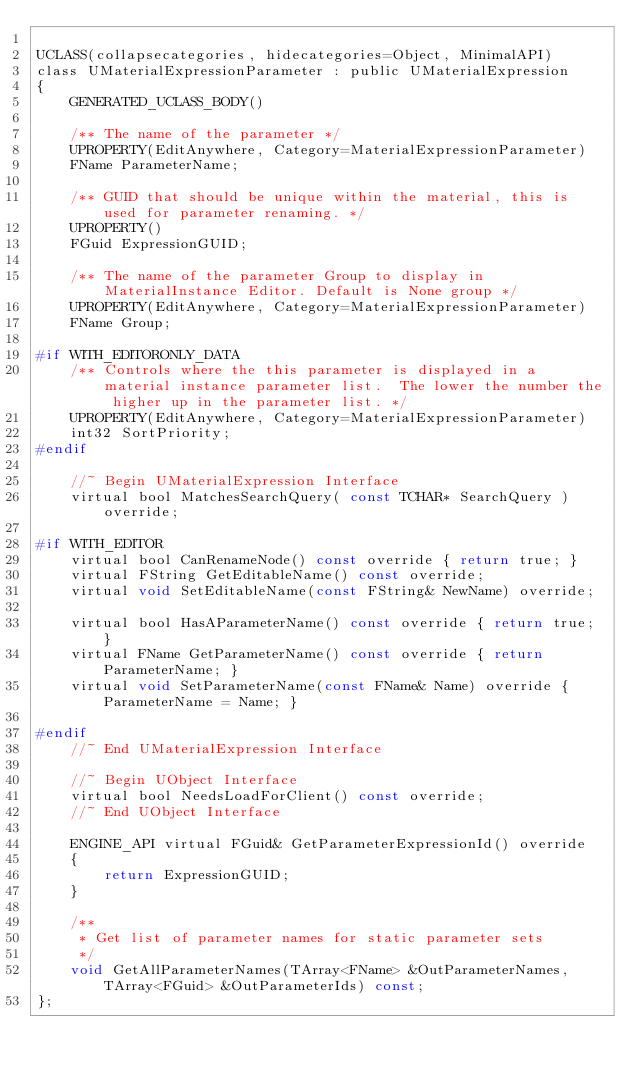<code> <loc_0><loc_0><loc_500><loc_500><_C_>
UCLASS(collapsecategories, hidecategories=Object, MinimalAPI)
class UMaterialExpressionParameter : public UMaterialExpression
{
	GENERATED_UCLASS_BODY()

	/** The name of the parameter */
	UPROPERTY(EditAnywhere, Category=MaterialExpressionParameter)
	FName ParameterName;

	/** GUID that should be unique within the material, this is used for parameter renaming. */
	UPROPERTY()
	FGuid ExpressionGUID;

	/** The name of the parameter Group to display in MaterialInstance Editor. Default is None group */
	UPROPERTY(EditAnywhere, Category=MaterialExpressionParameter)
	FName Group;

#if WITH_EDITORONLY_DATA
	/** Controls where the this parameter is displayed in a material instance parameter list.  The lower the number the higher up in the parameter list. */
	UPROPERTY(EditAnywhere, Category=MaterialExpressionParameter)
	int32 SortPriority;
#endif

	//~ Begin UMaterialExpression Interface
	virtual bool MatchesSearchQuery( const TCHAR* SearchQuery ) override;

#if WITH_EDITOR
	virtual bool CanRenameNode() const override { return true; }
	virtual FString GetEditableName() const override;
	virtual void SetEditableName(const FString& NewName) override;

	virtual bool HasAParameterName() const override { return true; }
	virtual FName GetParameterName() const override { return ParameterName; }
	virtual void SetParameterName(const FName& Name) override { ParameterName = Name; }

#endif
	//~ End UMaterialExpression Interface

	//~ Begin UObject Interface
	virtual bool NeedsLoadForClient() const override;
	//~ End UObject Interface

	ENGINE_API virtual FGuid& GetParameterExpressionId() override
	{
		return ExpressionGUID;
	}

	/**
	 * Get list of parameter names for static parameter sets
	 */
	void GetAllParameterNames(TArray<FName> &OutParameterNames, TArray<FGuid> &OutParameterIds) const;
};



</code> 